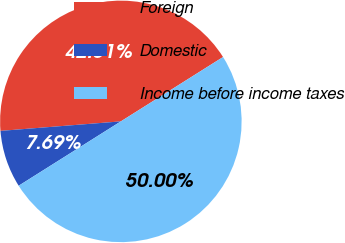Convert chart to OTSL. <chart><loc_0><loc_0><loc_500><loc_500><pie_chart><fcel>Foreign<fcel>Domestic<fcel>Income before income taxes<nl><fcel>42.31%<fcel>7.69%<fcel>50.0%<nl></chart> 